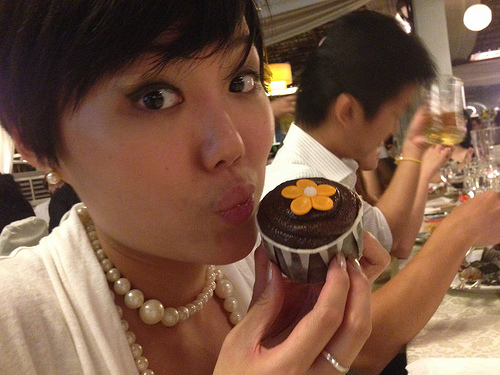Does the brown hair look long? No, the brown hair does not look long. It appears to be short. 